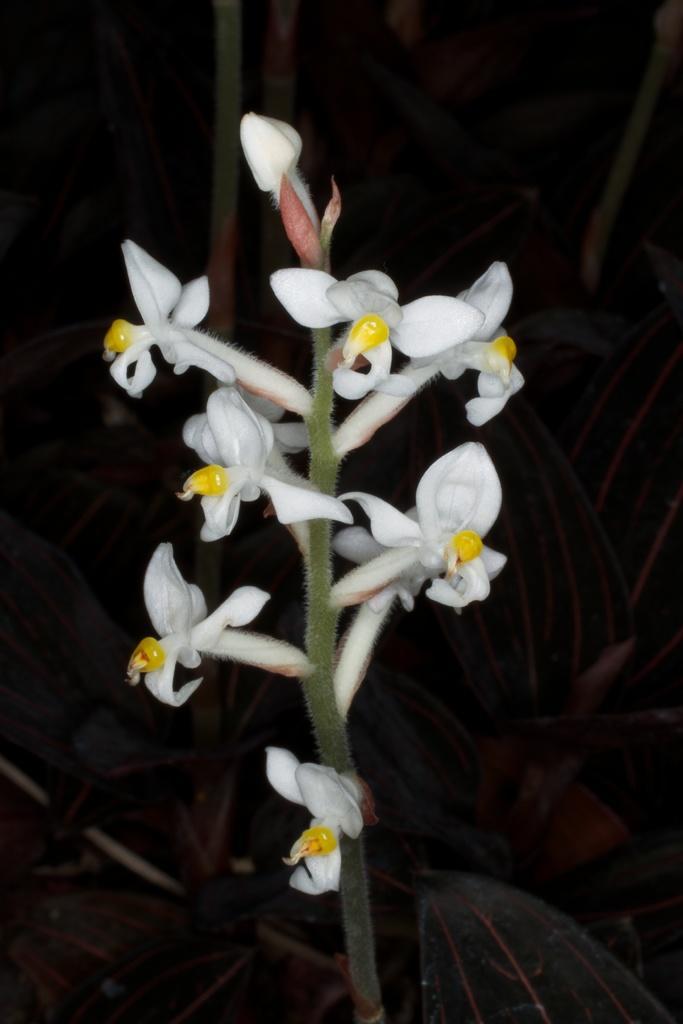How would you summarize this image in a sentence or two? In this image we can see a plant with flowers. 